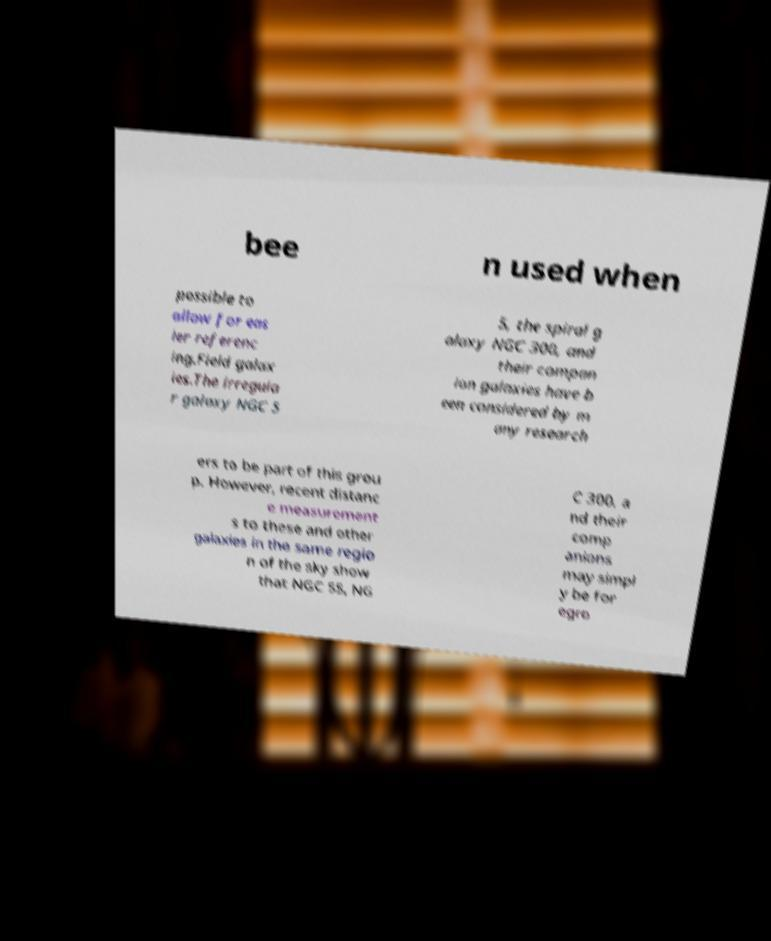I need the written content from this picture converted into text. Can you do that? bee n used when possible to allow for eas ier referenc ing.Field galax ies.The irregula r galaxy NGC 5 5, the spiral g alaxy NGC 300, and their compan ion galaxies have b een considered by m any research ers to be part of this grou p. However, recent distanc e measurement s to these and other galaxies in the same regio n of the sky show that NGC 55, NG C 300, a nd their comp anions may simpl y be for egro 